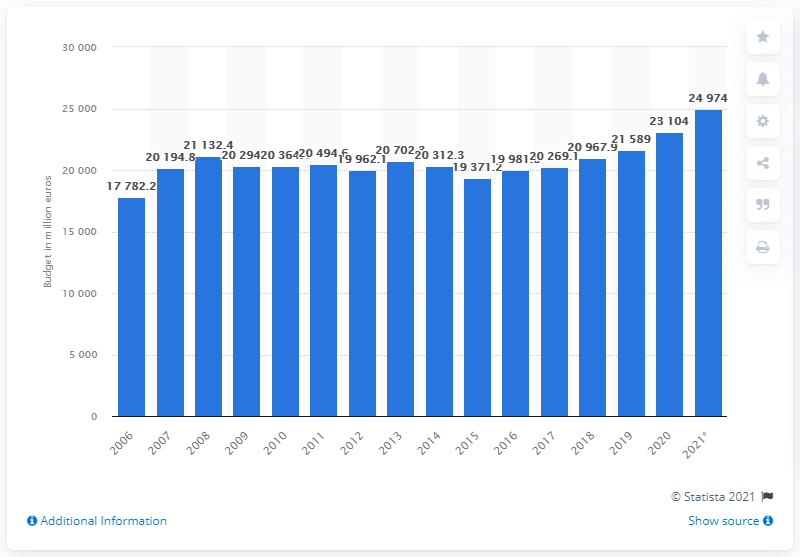Draw attention to some important aspects in this diagram. In 2021, the estimated annual expenditure of the Italian Ministry of Defense was 24,974... 